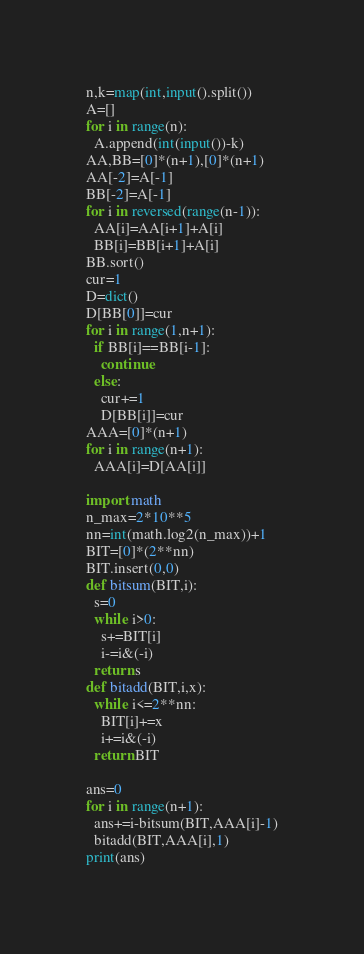<code> <loc_0><loc_0><loc_500><loc_500><_Python_>n,k=map(int,input().split())
A=[]
for i in range(n):
  A.append(int(input())-k)
AA,BB=[0]*(n+1),[0]*(n+1)
AA[-2]=A[-1]
BB[-2]=A[-1]
for i in reversed(range(n-1)):
  AA[i]=AA[i+1]+A[i]
  BB[i]=BB[i+1]+A[i]
BB.sort()
cur=1
D=dict()
D[BB[0]]=cur
for i in range(1,n+1):
  if BB[i]==BB[i-1]:
    continue
  else:
    cur+=1
    D[BB[i]]=cur
AAA=[0]*(n+1)
for i in range(n+1):
  AAA[i]=D[AA[i]]

import math
n_max=2*10**5
nn=int(math.log2(n_max))+1
BIT=[0]*(2**nn)
BIT.insert(0,0)
def bitsum(BIT,i):
  s=0
  while i>0:
    s+=BIT[i]
    i-=i&(-i)
  return s
def bitadd(BIT,i,x):
  while i<=2**nn:
    BIT[i]+=x
    i+=i&(-i)
  return BIT

ans=0
for i in range(n+1):
  ans+=i-bitsum(BIT,AAA[i]-1)
  bitadd(BIT,AAA[i],1)
print(ans)
</code> 